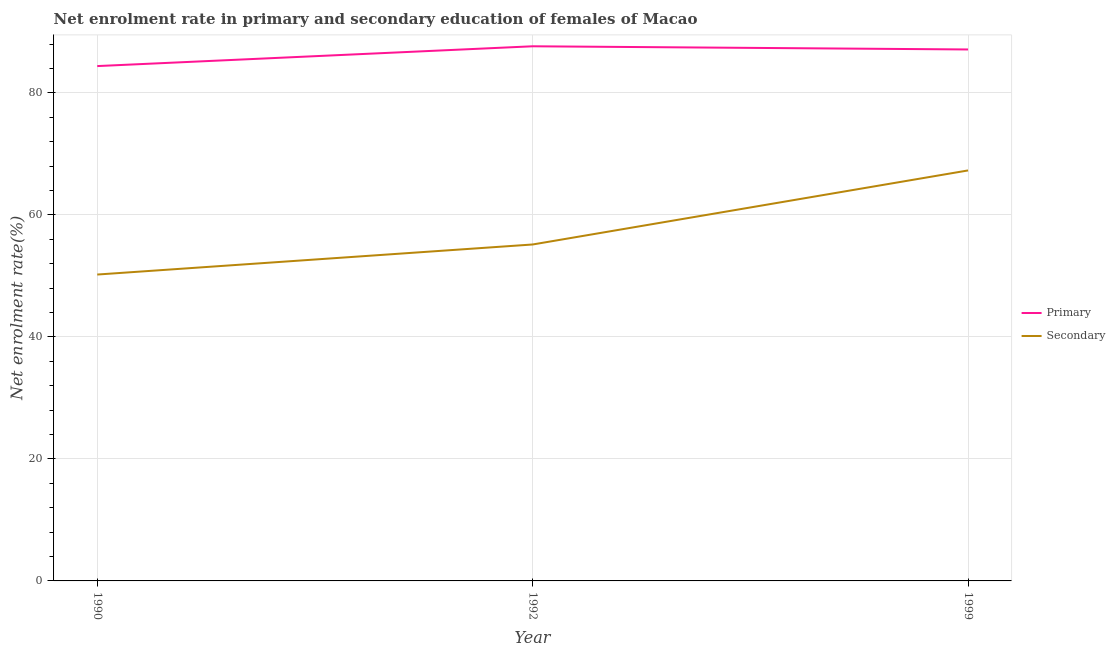How many different coloured lines are there?
Your answer should be compact. 2. Does the line corresponding to enrollment rate in primary education intersect with the line corresponding to enrollment rate in secondary education?
Your answer should be very brief. No. Is the number of lines equal to the number of legend labels?
Offer a very short reply. Yes. What is the enrollment rate in secondary education in 1990?
Provide a short and direct response. 50.22. Across all years, what is the maximum enrollment rate in primary education?
Make the answer very short. 87.64. Across all years, what is the minimum enrollment rate in primary education?
Your answer should be very brief. 84.4. In which year was the enrollment rate in secondary education maximum?
Offer a terse response. 1999. What is the total enrollment rate in secondary education in the graph?
Your response must be concise. 172.67. What is the difference between the enrollment rate in secondary education in 1992 and that in 1999?
Your response must be concise. -12.14. What is the difference between the enrollment rate in secondary education in 1999 and the enrollment rate in primary education in 1990?
Your answer should be very brief. -17.11. What is the average enrollment rate in secondary education per year?
Your response must be concise. 57.56. In the year 1990, what is the difference between the enrollment rate in secondary education and enrollment rate in primary education?
Provide a succinct answer. -34.17. What is the ratio of the enrollment rate in primary education in 1990 to that in 1992?
Provide a succinct answer. 0.96. Is the enrollment rate in secondary education in 1992 less than that in 1999?
Offer a terse response. Yes. What is the difference between the highest and the second highest enrollment rate in primary education?
Provide a short and direct response. 0.52. What is the difference between the highest and the lowest enrollment rate in secondary education?
Offer a terse response. 17.07. Is the sum of the enrollment rate in primary education in 1990 and 1999 greater than the maximum enrollment rate in secondary education across all years?
Offer a very short reply. Yes. What is the difference between two consecutive major ticks on the Y-axis?
Give a very brief answer. 20. Where does the legend appear in the graph?
Offer a very short reply. Center right. How many legend labels are there?
Make the answer very short. 2. How are the legend labels stacked?
Your response must be concise. Vertical. What is the title of the graph?
Give a very brief answer. Net enrolment rate in primary and secondary education of females of Macao. What is the label or title of the Y-axis?
Your answer should be very brief. Net enrolment rate(%). What is the Net enrolment rate(%) in Primary in 1990?
Provide a short and direct response. 84.4. What is the Net enrolment rate(%) in Secondary in 1990?
Provide a succinct answer. 50.22. What is the Net enrolment rate(%) in Primary in 1992?
Provide a short and direct response. 87.64. What is the Net enrolment rate(%) in Secondary in 1992?
Keep it short and to the point. 55.15. What is the Net enrolment rate(%) in Primary in 1999?
Provide a succinct answer. 87.12. What is the Net enrolment rate(%) of Secondary in 1999?
Your answer should be very brief. 67.29. Across all years, what is the maximum Net enrolment rate(%) of Primary?
Your answer should be very brief. 87.64. Across all years, what is the maximum Net enrolment rate(%) of Secondary?
Your answer should be very brief. 67.29. Across all years, what is the minimum Net enrolment rate(%) in Primary?
Provide a succinct answer. 84.4. Across all years, what is the minimum Net enrolment rate(%) in Secondary?
Offer a very short reply. 50.22. What is the total Net enrolment rate(%) of Primary in the graph?
Keep it short and to the point. 259.16. What is the total Net enrolment rate(%) of Secondary in the graph?
Offer a terse response. 172.67. What is the difference between the Net enrolment rate(%) in Primary in 1990 and that in 1992?
Your response must be concise. -3.24. What is the difference between the Net enrolment rate(%) in Secondary in 1990 and that in 1992?
Provide a short and direct response. -4.93. What is the difference between the Net enrolment rate(%) of Primary in 1990 and that in 1999?
Provide a short and direct response. -2.72. What is the difference between the Net enrolment rate(%) of Secondary in 1990 and that in 1999?
Your answer should be compact. -17.07. What is the difference between the Net enrolment rate(%) in Primary in 1992 and that in 1999?
Give a very brief answer. 0.52. What is the difference between the Net enrolment rate(%) of Secondary in 1992 and that in 1999?
Keep it short and to the point. -12.14. What is the difference between the Net enrolment rate(%) of Primary in 1990 and the Net enrolment rate(%) of Secondary in 1992?
Provide a short and direct response. 29.25. What is the difference between the Net enrolment rate(%) in Primary in 1990 and the Net enrolment rate(%) in Secondary in 1999?
Keep it short and to the point. 17.11. What is the difference between the Net enrolment rate(%) in Primary in 1992 and the Net enrolment rate(%) in Secondary in 1999?
Provide a succinct answer. 20.35. What is the average Net enrolment rate(%) in Primary per year?
Provide a short and direct response. 86.39. What is the average Net enrolment rate(%) of Secondary per year?
Offer a very short reply. 57.56. In the year 1990, what is the difference between the Net enrolment rate(%) of Primary and Net enrolment rate(%) of Secondary?
Provide a short and direct response. 34.17. In the year 1992, what is the difference between the Net enrolment rate(%) of Primary and Net enrolment rate(%) of Secondary?
Make the answer very short. 32.49. In the year 1999, what is the difference between the Net enrolment rate(%) in Primary and Net enrolment rate(%) in Secondary?
Offer a terse response. 19.83. What is the ratio of the Net enrolment rate(%) of Secondary in 1990 to that in 1992?
Your answer should be compact. 0.91. What is the ratio of the Net enrolment rate(%) in Primary in 1990 to that in 1999?
Keep it short and to the point. 0.97. What is the ratio of the Net enrolment rate(%) in Secondary in 1990 to that in 1999?
Your answer should be compact. 0.75. What is the ratio of the Net enrolment rate(%) of Secondary in 1992 to that in 1999?
Keep it short and to the point. 0.82. What is the difference between the highest and the second highest Net enrolment rate(%) in Primary?
Offer a very short reply. 0.52. What is the difference between the highest and the second highest Net enrolment rate(%) of Secondary?
Give a very brief answer. 12.14. What is the difference between the highest and the lowest Net enrolment rate(%) of Primary?
Provide a short and direct response. 3.24. What is the difference between the highest and the lowest Net enrolment rate(%) of Secondary?
Give a very brief answer. 17.07. 